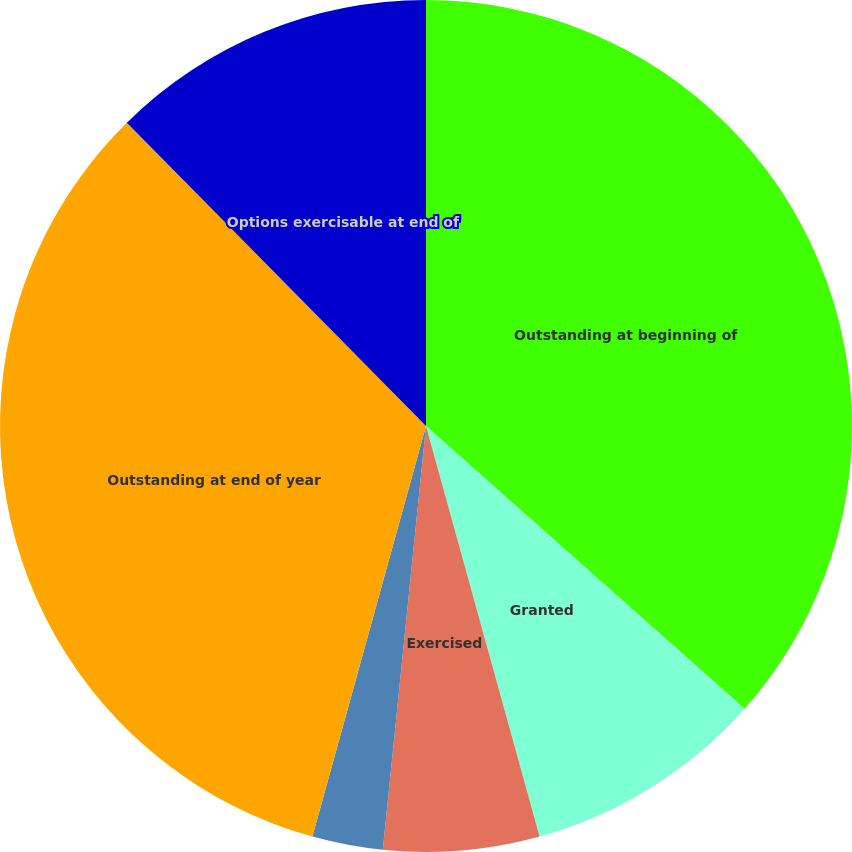Convert chart to OTSL. <chart><loc_0><loc_0><loc_500><loc_500><pie_chart><fcel>Outstanding at beginning of<fcel>Granted<fcel>Exercised<fcel>Canceled<fcel>Outstanding at end of year<fcel>Options exercisable at end of<nl><fcel>36.55%<fcel>9.15%<fcel>5.91%<fcel>2.68%<fcel>33.31%<fcel>12.39%<nl></chart> 